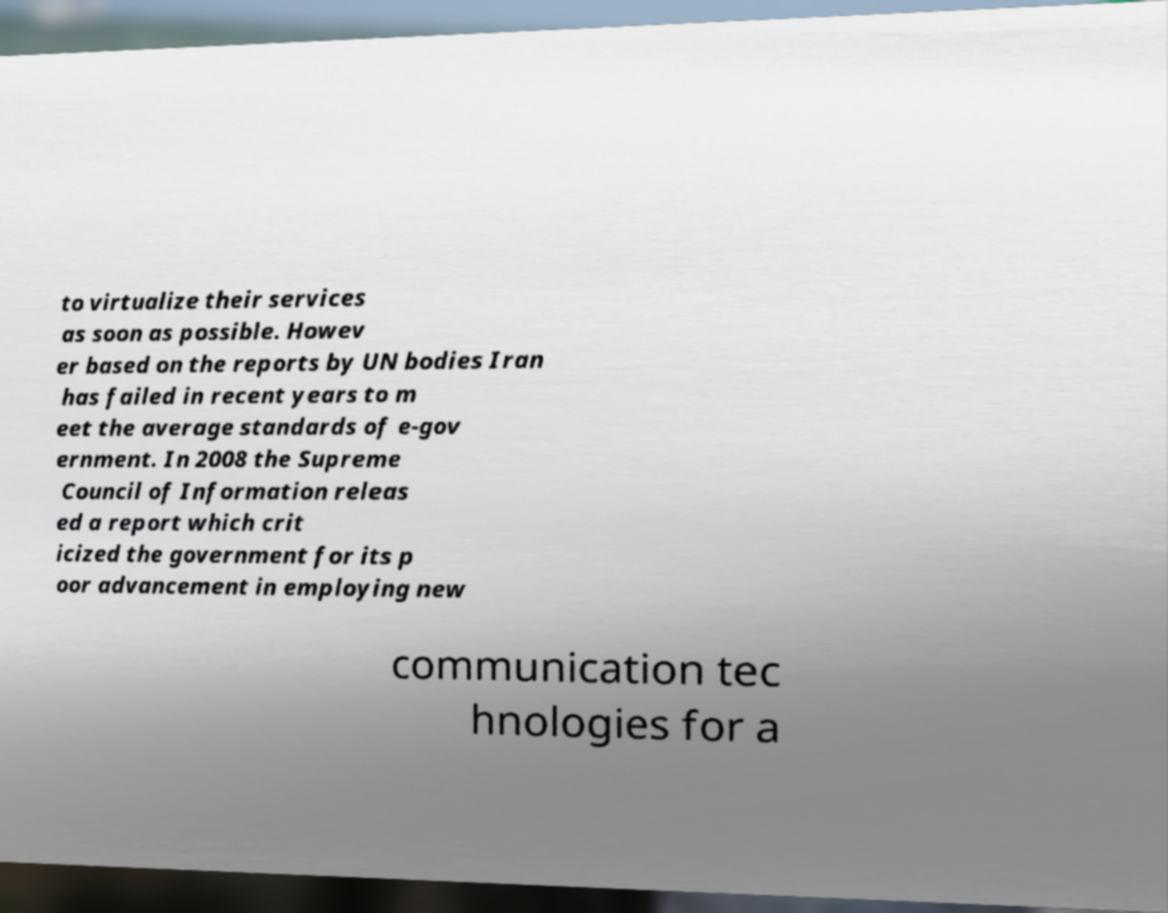I need the written content from this picture converted into text. Can you do that? to virtualize their services as soon as possible. Howev er based on the reports by UN bodies Iran has failed in recent years to m eet the average standards of e-gov ernment. In 2008 the Supreme Council of Information releas ed a report which crit icized the government for its p oor advancement in employing new communication tec hnologies for a 